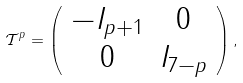Convert formula to latex. <formula><loc_0><loc_0><loc_500><loc_500>\mathcal { T } ^ { p } = \left ( \begin{array} { c c } - I _ { p + 1 } & 0 \\ 0 & I _ { 7 - p } \end{array} \right ) ,</formula> 